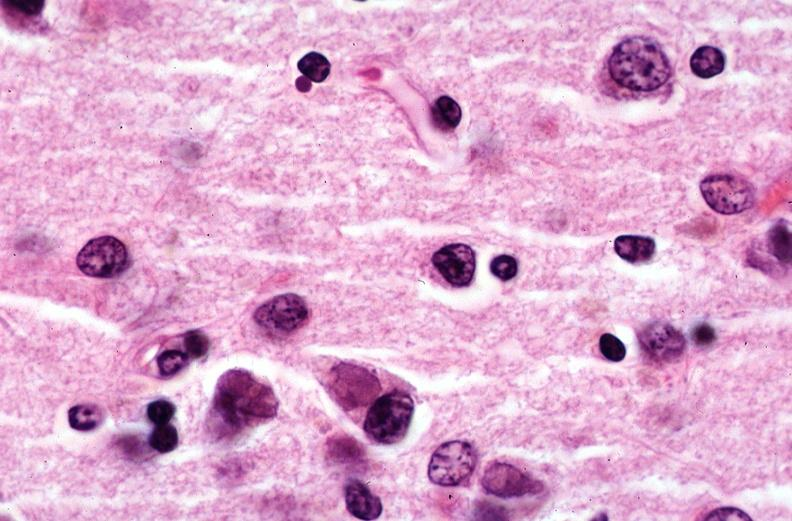does chronic lymphocytic leukemia show brain, pick 's disease?
Answer the question using a single word or phrase. No 